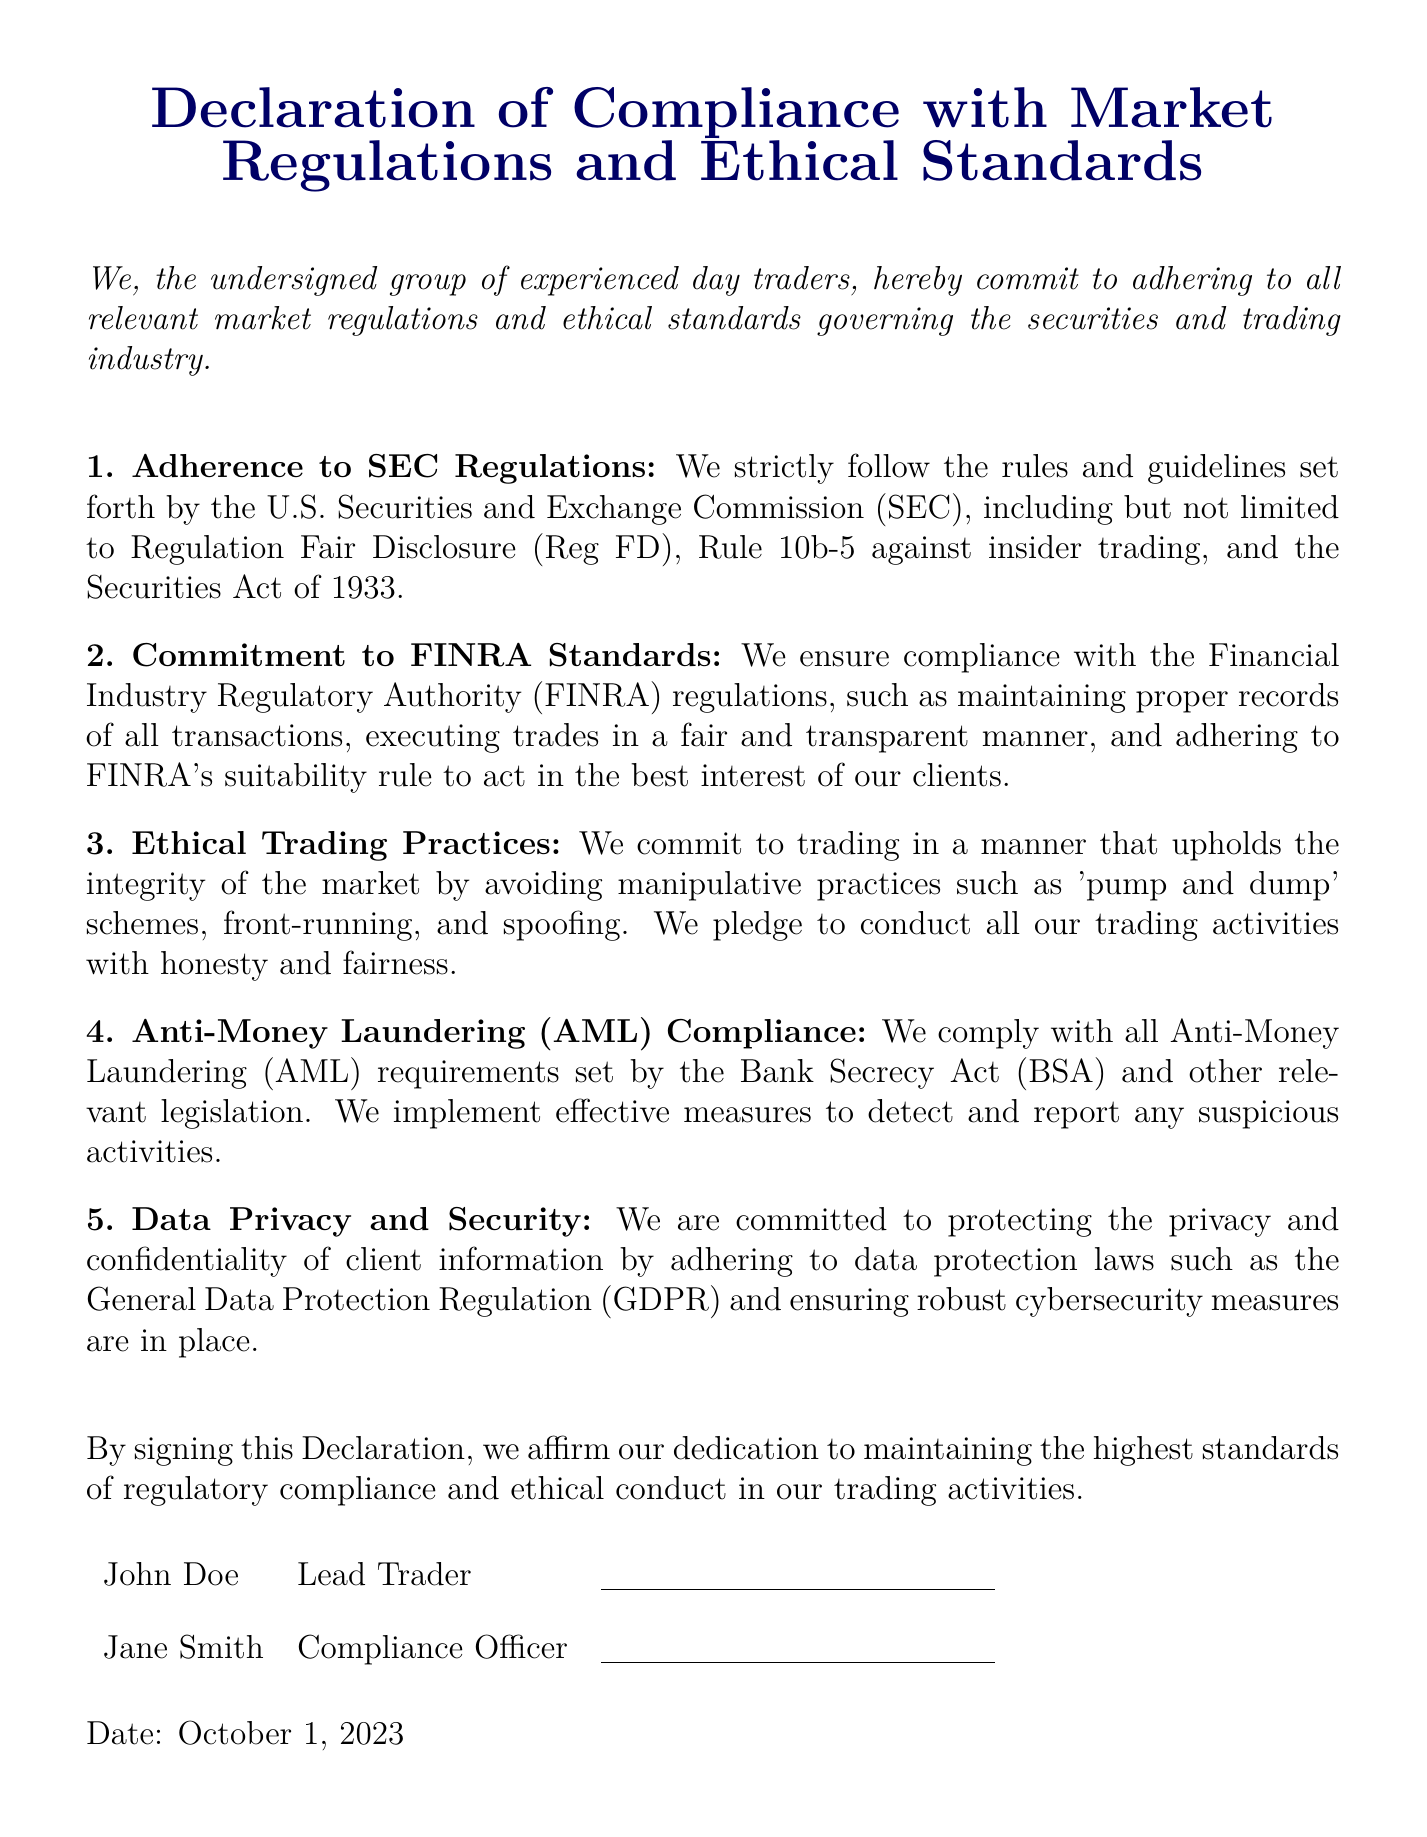What is the title of the document? The title is the main heading provided at the top of the document, summarizing the key theme.
Answer: Declaration of Compliance with Market Regulations and Ethical Standards Who are the undersigned members? The members are specified in the section where their names and titles are listed in the signing area.
Answer: John Doe, Jane Smith What is the date of the declaration? The date is specified at the bottom of the document beneath the signatures, stating when the declaration was made.
Answer: October 1, 2023 What regulatory body's rules do the traders adhere to? The document mentions the U.S. Securities and Exchange Commission as a key regulatory body they comply with.
Answer: SEC Which ethical practice is explicitly mentioned in the declaration? The document outlines several ethical practices, emphasizing the conduct expected of traders in a fair market.
Answer: Honest and fairness What is the commitment related to Anti-Money Laundering? The document specifies compliance with the Bank Secrecy Act and outlines their commitment to detecting suspicious activities.
Answer: Comply with all Anti-Money Laundering (AML) requirements What does the FINRA regulation require from the traders? The document mentions the necessity to maintain proper records of transactions and to act in clients' best interest as part of FINRA standards.
Answer: Proper records of all transactions What is the tone of the declaration? The tone can be inferred from the language used throughout the document, focusing on commitment and compliance with regulatory standards.
Answer: Committed 